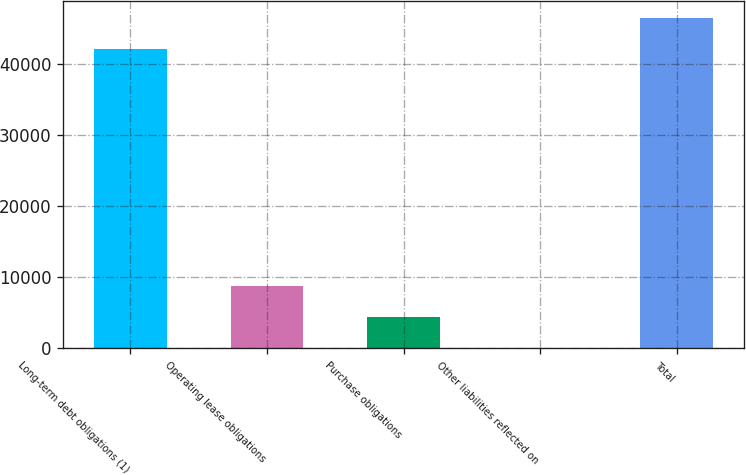Convert chart. <chart><loc_0><loc_0><loc_500><loc_500><bar_chart><fcel>Long-term debt obligations (1)<fcel>Operating lease obligations<fcel>Purchase obligations<fcel>Other liabilities reflected on<fcel>Total<nl><fcel>42112<fcel>8824.2<fcel>4429.6<fcel>35<fcel>46506.6<nl></chart> 